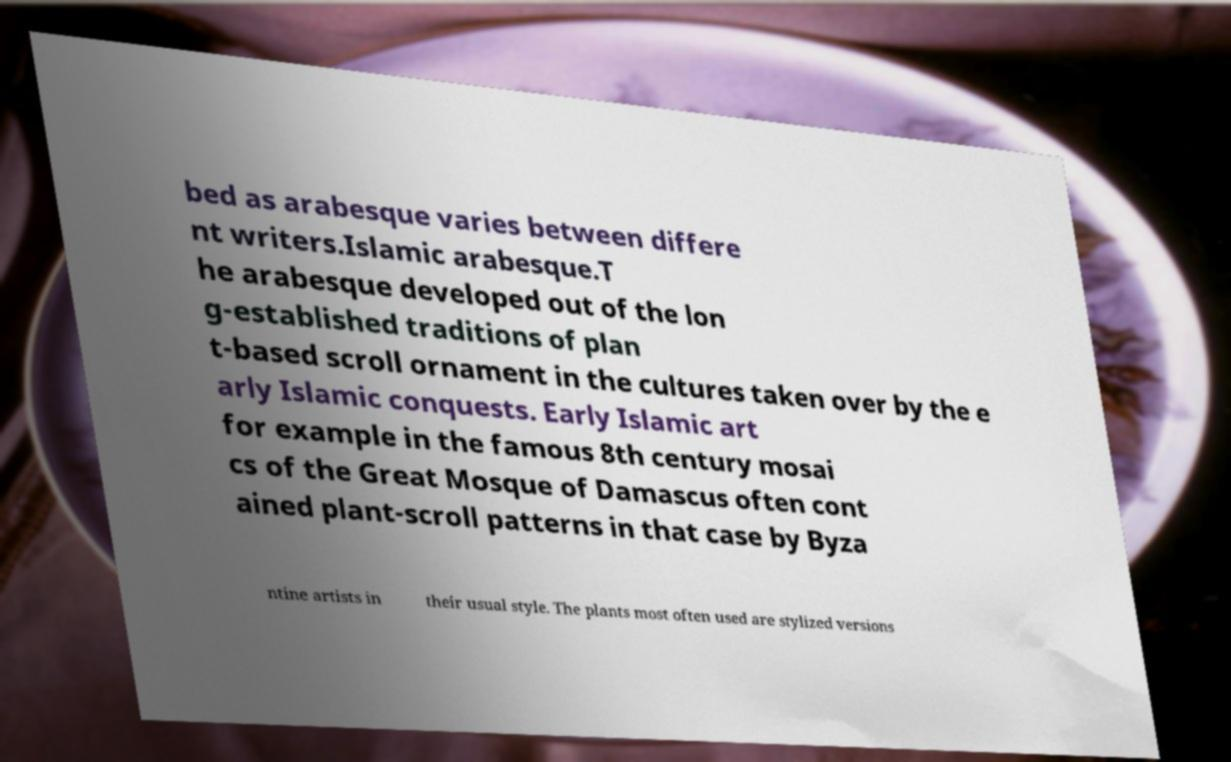Please read and relay the text visible in this image. What does it say? bed as arabesque varies between differe nt writers.Islamic arabesque.T he arabesque developed out of the lon g-established traditions of plan t-based scroll ornament in the cultures taken over by the e arly Islamic conquests. Early Islamic art for example in the famous 8th century mosai cs of the Great Mosque of Damascus often cont ained plant-scroll patterns in that case by Byza ntine artists in their usual style. The plants most often used are stylized versions 